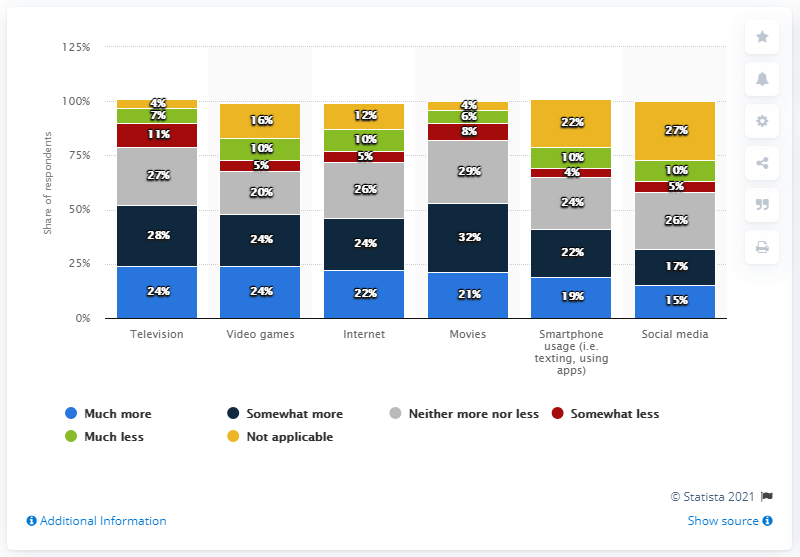List a handful of essential elements in this visual. The highest percentage value in the yellow bar is 27%. The sum of the more and less percentage value in social media is 25%. 